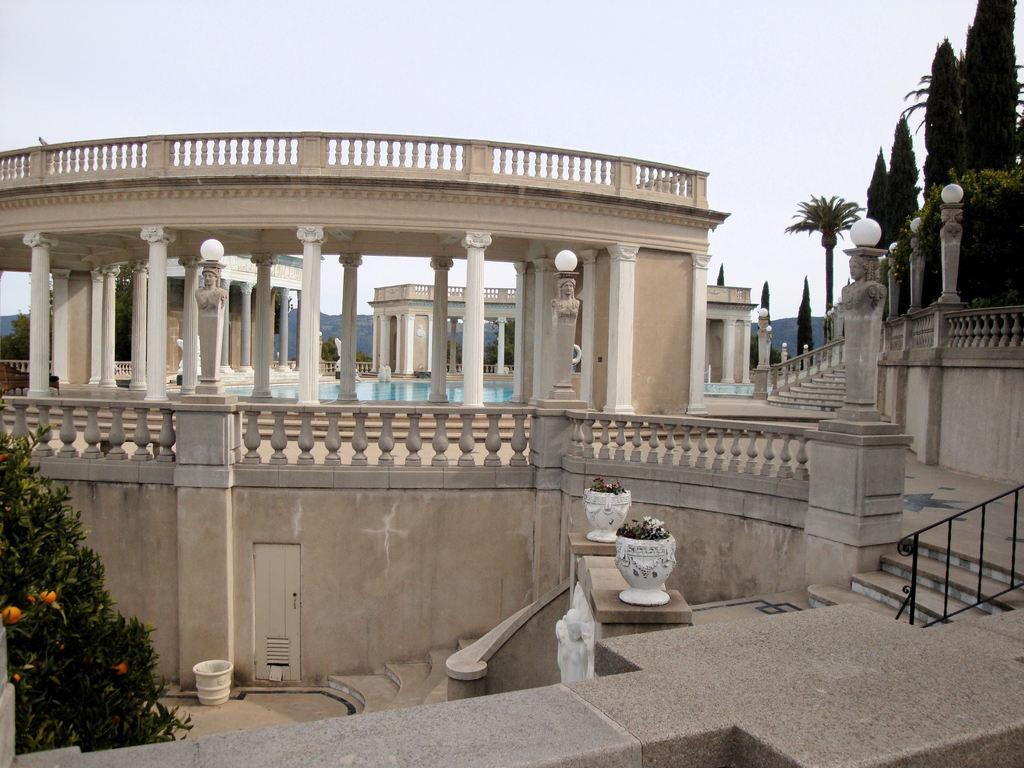Could you give a brief overview of what you see in this image? In this picture we can see monument. On the bottom left corner there is a plant and many fruits. Here we can see your pot and plants. On the right we can see many trees and lights. In the background we can see mountain. in the center of the building we can see swimming pool. On the top we can see sky and clouds. 